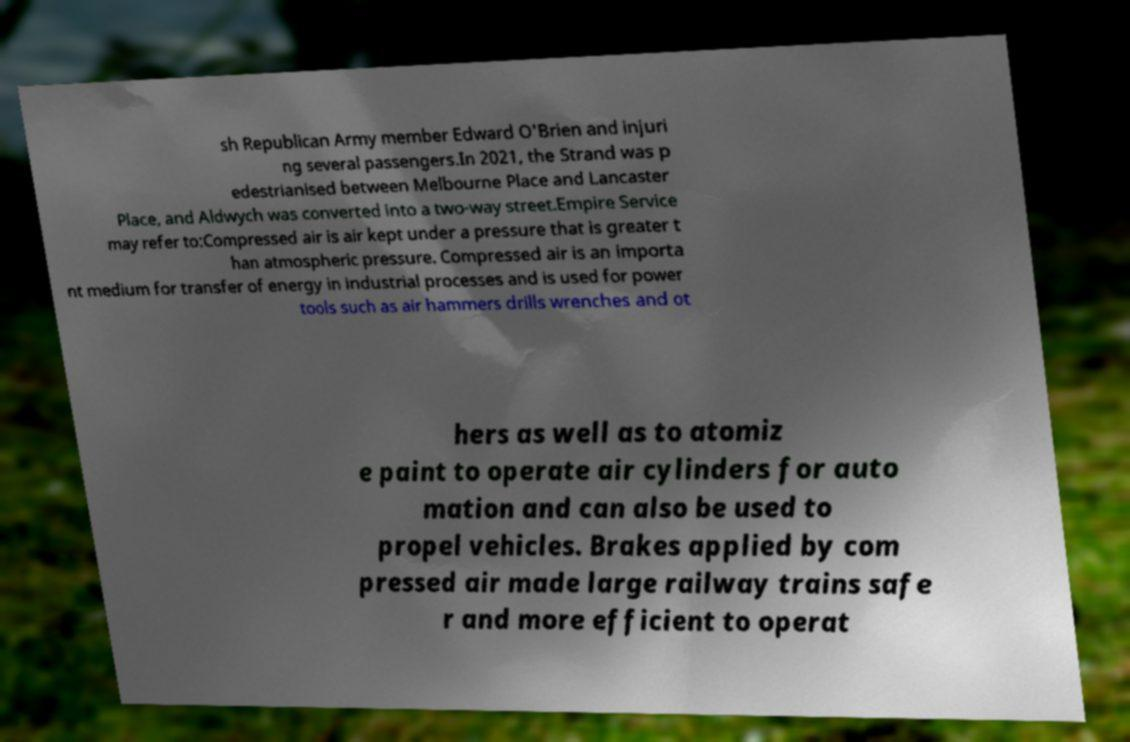Can you read and provide the text displayed in the image?This photo seems to have some interesting text. Can you extract and type it out for me? sh Republican Army member Edward O'Brien and injuri ng several passengers.In 2021, the Strand was p edestrianised between Melbourne Place and Lancaster Place, and Aldwych was converted into a two-way street.Empire Service may refer to:Compressed air is air kept under a pressure that is greater t han atmospheric pressure. Compressed air is an importa nt medium for transfer of energy in industrial processes and is used for power tools such as air hammers drills wrenches and ot hers as well as to atomiz e paint to operate air cylinders for auto mation and can also be used to propel vehicles. Brakes applied by com pressed air made large railway trains safe r and more efficient to operat 